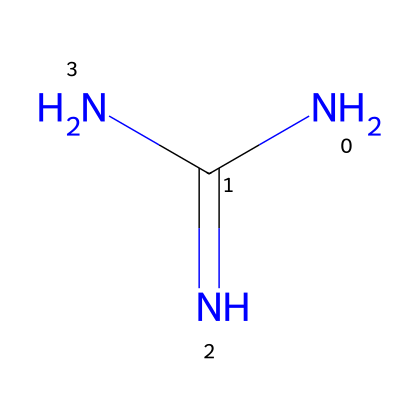What is the molecular formula of guanidine? The SMILES representation NC(=N)N indicates that there are one nitrogen atom attached to a carbon atom connected to another nitrogen atom, and another nitrogen atom is also bonded to the carbon. Counting the atoms gives a total of 4 nitrogen atoms and 1 carbon atom. Thus, the molecular formula is C1H7N5.
Answer: C1H7N5 How many hydrogen atoms are in guanidine? By analyzing the molecular formula derived from the SMILES representation, C1H7N5 indicates that there are 7 hydrogen atoms.
Answer: 7 What type of bonding is present in guanidine? The SMILES structure shows a double bond between the carbon and one nitrogen (C=N) and single bonds between other atoms, indicating the presence of both single and double bonds. The combination of these types of bonds qualifies guanidine as having both covalent bonding.
Answer: covalent Which functional groups are present in guanidine? The SMILES representation reveals the presence of amino groups (–NH2) due to the nitrogen atoms associated with the carbon atom. This indicates that guanidine possesses primary amine functional groups.
Answer: amine Is guanidine a strong or weak superbase? Guanidine is known as a strong superbase due to its ability to deprotonate weak acids due to the high basicity associated with the multiple nitrogen atoms in its structure, which increases its electron availability.
Answer: strong How many resonance structures can guanidine have? Guanidine can have multiple resonance forms due to the different placements of electron pairs involving its nitrogen atoms, primarily due to the presence of the C=N double bond. The specific number of resonance structures can be derived through resonance theory, typically resulting in 3 significant resonance forms.
Answer: 3 